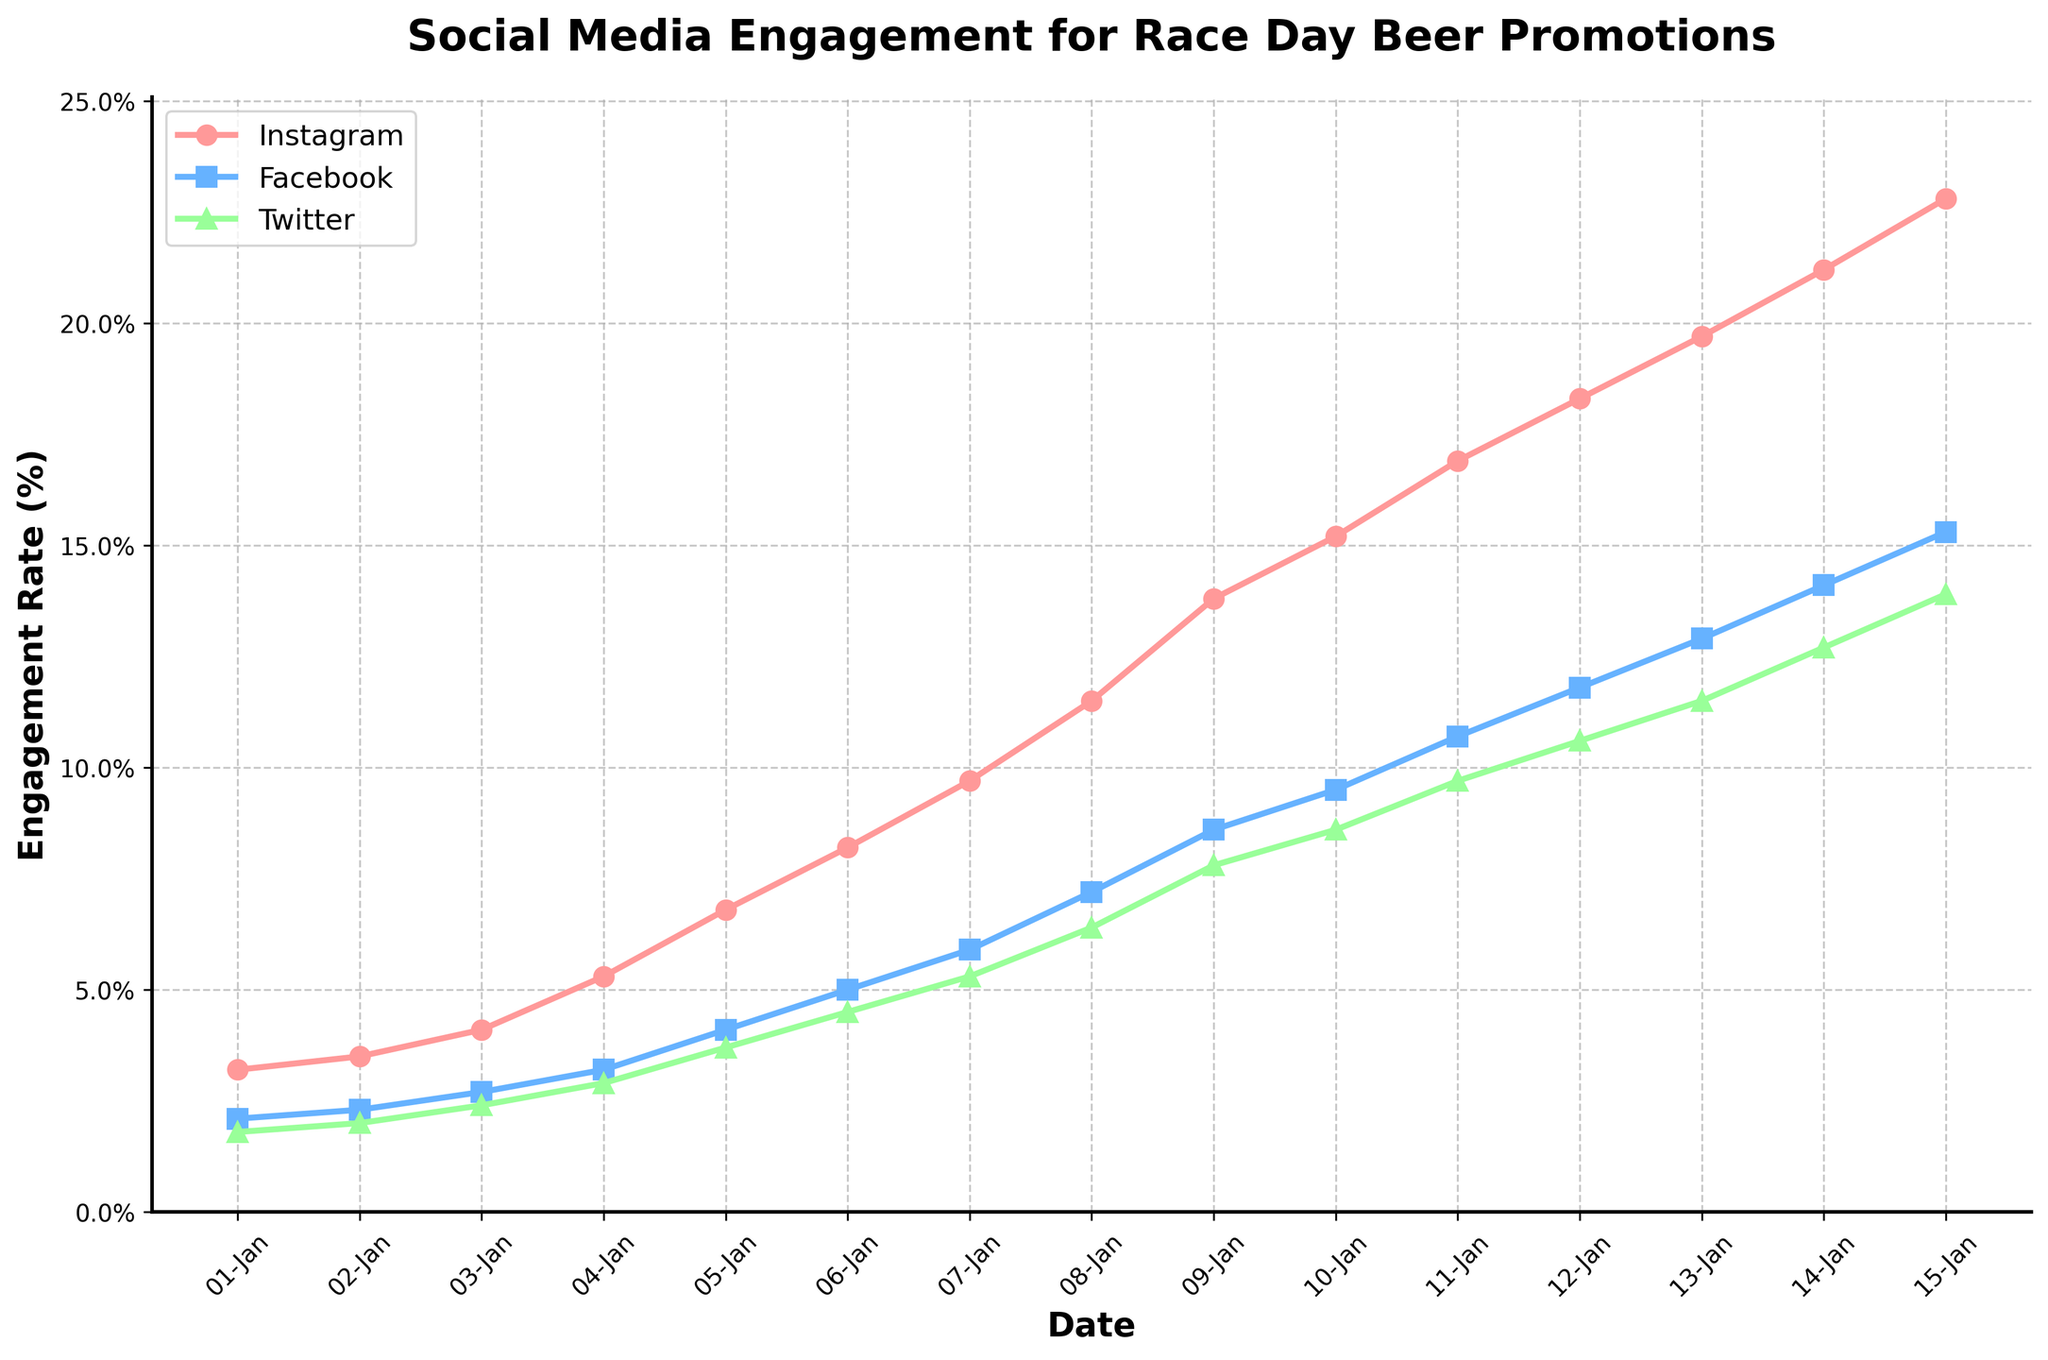What is the Instagram engagement rate on July 3rd, 2023? To find this, look at the Instagram data point corresponding to the date July 3rd, 2023.
Answer: 15.2% Which platform had the highest engagement rate on August 7th, 2023? On August 7th, 2023, Instagram had the highest engagement rate at 22.8%, compared to Facebook at 15.3% and Twitter at 13.9%.
Answer: Instagram By how much did the Instagram engagement rate increase from May 1st to August 7th, 2023? Subtract Instagram's rate on May 1st (3.2%) from its rate on August 7th (22.8%). The increase is 22.8% - 3.2% = 19.6%.
Answer: 19.6% Which two platforms showed the largest difference in engagement rates on May 22nd, 2023? On May 22nd, Instagram was 5.3%, Facebook was 3.2%, and Twitter was 2.9%. The largest difference is between Instagram and Twitter, which is 5.3% - 2.9% = 2.4%.
Answer: Instagram and Twitter What was the average engagement rate across all three platforms on June 26th, 2023? Sum the engagement rates on June 26th for Instagram (13.8%), Facebook (8.6%), and Twitter (7.8%) and divide by 3. (13.8 + 8.6 + 7.8) / 3 = 10.07%
Answer: 10.07% Did Facebook's engagement rate ever exceed 10% during the observed time period? Facebook's engagement rate reached 10.7% by July 10th, 2023.
Answer: Yes By how much did Twitter's engagement rate change between May 15th and June 12th, 2023? Subtract the rate on May 15th (2.4%) from the rate on June 12th (5.3%). The change is 5.3% - 2.4% = 2.9%.
Answer: 2.9% On what date did Instagram's engagement rate reach 10%? Instagram's engagement rate surpassed 10% on June 19th, 2023, with a rate of 11.5%.
Answer: June 19th, 2023 Which platform had the slowest growth rate in engagement from May 1st to August 7th, 2023? The increase for each platform is: Instagram: 22.8%-3.2%=19.6%, Facebook: 15.3%-2.1%=13.2%, Twitter: 13.9%-1.8%=12.1%. Twitter had the slowest growth rate.
Answer: Twitter 